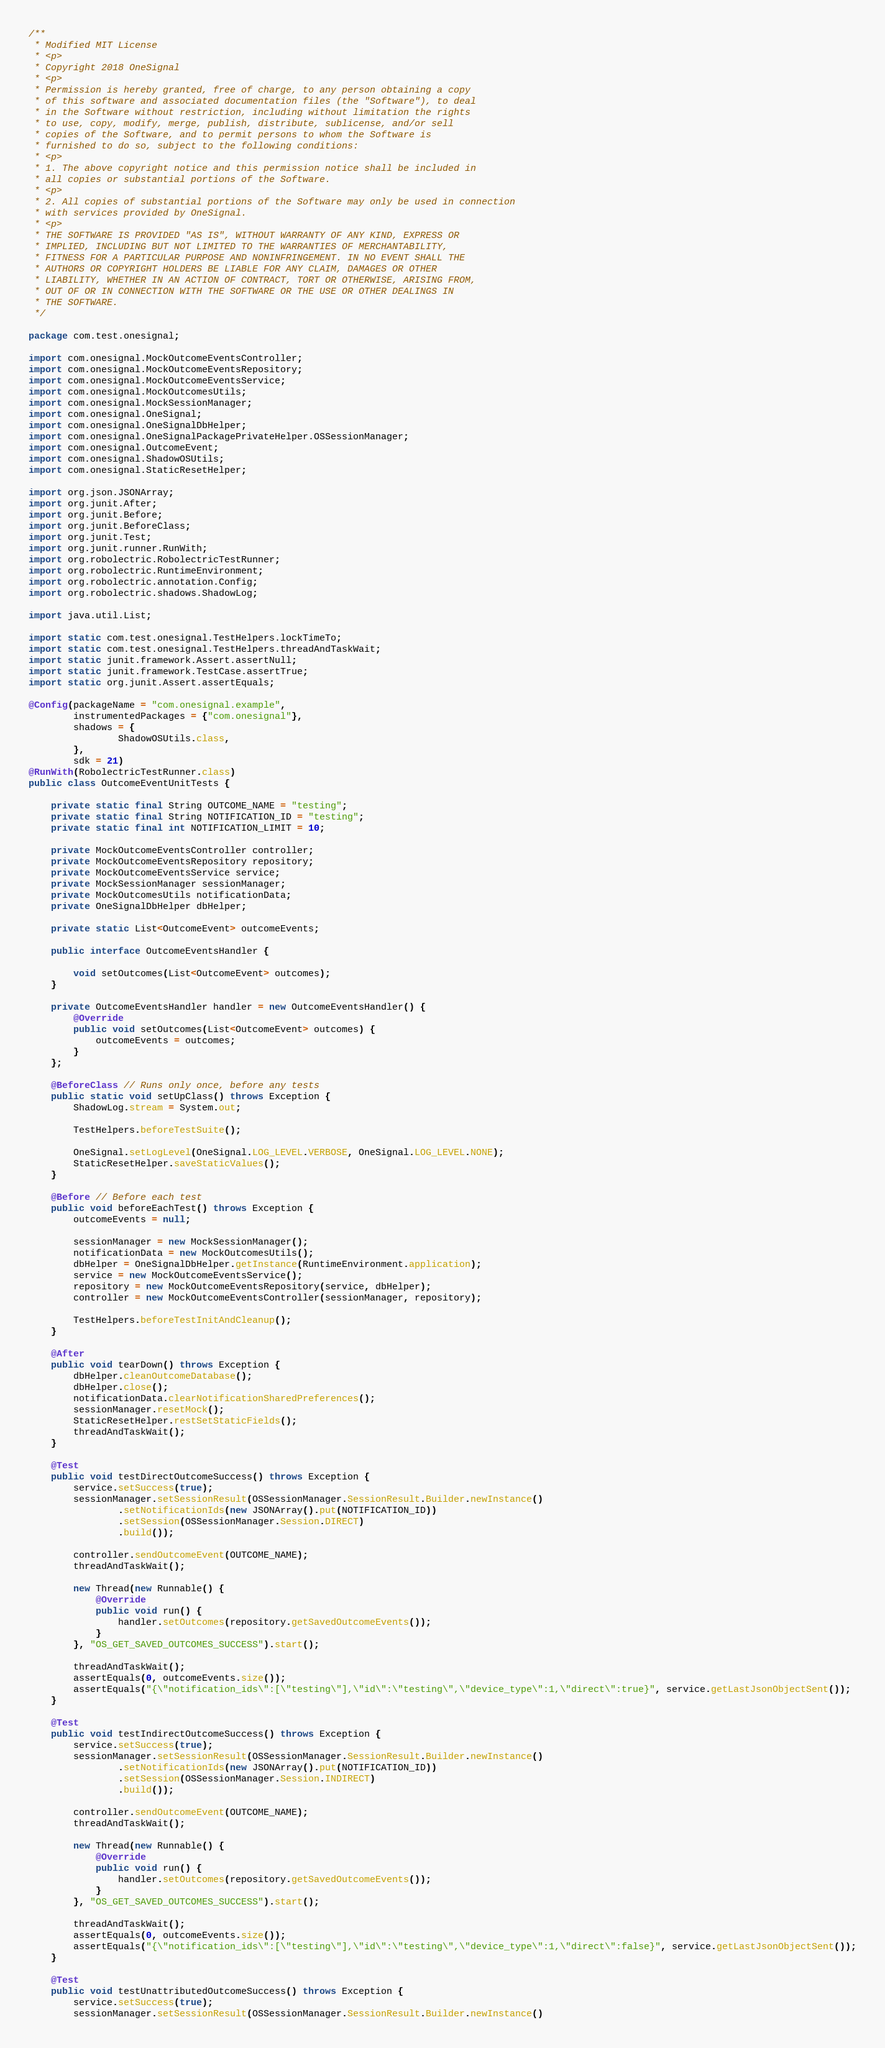Convert code to text. <code><loc_0><loc_0><loc_500><loc_500><_Java_>/**
 * Modified MIT License
 * <p>
 * Copyright 2018 OneSignal
 * <p>
 * Permission is hereby granted, free of charge, to any person obtaining a copy
 * of this software and associated documentation files (the "Software"), to deal
 * in the Software without restriction, including without limitation the rights
 * to use, copy, modify, merge, publish, distribute, sublicense, and/or sell
 * copies of the Software, and to permit persons to whom the Software is
 * furnished to do so, subject to the following conditions:
 * <p>
 * 1. The above copyright notice and this permission notice shall be included in
 * all copies or substantial portions of the Software.
 * <p>
 * 2. All copies of substantial portions of the Software may only be used in connection
 * with services provided by OneSignal.
 * <p>
 * THE SOFTWARE IS PROVIDED "AS IS", WITHOUT WARRANTY OF ANY KIND, EXPRESS OR
 * IMPLIED, INCLUDING BUT NOT LIMITED TO THE WARRANTIES OF MERCHANTABILITY,
 * FITNESS FOR A PARTICULAR PURPOSE AND NONINFRINGEMENT. IN NO EVENT SHALL THE
 * AUTHORS OR COPYRIGHT HOLDERS BE LIABLE FOR ANY CLAIM, DAMAGES OR OTHER
 * LIABILITY, WHETHER IN AN ACTION OF CONTRACT, TORT OR OTHERWISE, ARISING FROM,
 * OUT OF OR IN CONNECTION WITH THE SOFTWARE OR THE USE OR OTHER DEALINGS IN
 * THE SOFTWARE.
 */

package com.test.onesignal;

import com.onesignal.MockOutcomeEventsController;
import com.onesignal.MockOutcomeEventsRepository;
import com.onesignal.MockOutcomeEventsService;
import com.onesignal.MockOutcomesUtils;
import com.onesignal.MockSessionManager;
import com.onesignal.OneSignal;
import com.onesignal.OneSignalDbHelper;
import com.onesignal.OneSignalPackagePrivateHelper.OSSessionManager;
import com.onesignal.OutcomeEvent;
import com.onesignal.ShadowOSUtils;
import com.onesignal.StaticResetHelper;

import org.json.JSONArray;
import org.junit.After;
import org.junit.Before;
import org.junit.BeforeClass;
import org.junit.Test;
import org.junit.runner.RunWith;
import org.robolectric.RobolectricTestRunner;
import org.robolectric.RuntimeEnvironment;
import org.robolectric.annotation.Config;
import org.robolectric.shadows.ShadowLog;

import java.util.List;

import static com.test.onesignal.TestHelpers.lockTimeTo;
import static com.test.onesignal.TestHelpers.threadAndTaskWait;
import static junit.framework.Assert.assertNull;
import static junit.framework.TestCase.assertTrue;
import static org.junit.Assert.assertEquals;

@Config(packageName = "com.onesignal.example",
        instrumentedPackages = {"com.onesignal"},
        shadows = {
                ShadowOSUtils.class,
        },
        sdk = 21)
@RunWith(RobolectricTestRunner.class)
public class OutcomeEventUnitTests {

    private static final String OUTCOME_NAME = "testing";
    private static final String NOTIFICATION_ID = "testing";
    private static final int NOTIFICATION_LIMIT = 10;

    private MockOutcomeEventsController controller;
    private MockOutcomeEventsRepository repository;
    private MockOutcomeEventsService service;
    private MockSessionManager sessionManager;
    private MockOutcomesUtils notificationData;
    private OneSignalDbHelper dbHelper;

    private static List<OutcomeEvent> outcomeEvents;

    public interface OutcomeEventsHandler {

        void setOutcomes(List<OutcomeEvent> outcomes);
    }

    private OutcomeEventsHandler handler = new OutcomeEventsHandler() {
        @Override
        public void setOutcomes(List<OutcomeEvent> outcomes) {
            outcomeEvents = outcomes;
        }
    };

    @BeforeClass // Runs only once, before any tests
    public static void setUpClass() throws Exception {
        ShadowLog.stream = System.out;

        TestHelpers.beforeTestSuite();

        OneSignal.setLogLevel(OneSignal.LOG_LEVEL.VERBOSE, OneSignal.LOG_LEVEL.NONE);
        StaticResetHelper.saveStaticValues();
    }

    @Before // Before each test
    public void beforeEachTest() throws Exception {
        outcomeEvents = null;

        sessionManager = new MockSessionManager();
        notificationData = new MockOutcomesUtils();
        dbHelper = OneSignalDbHelper.getInstance(RuntimeEnvironment.application);
        service = new MockOutcomeEventsService();
        repository = new MockOutcomeEventsRepository(service, dbHelper);
        controller = new MockOutcomeEventsController(sessionManager, repository);

        TestHelpers.beforeTestInitAndCleanup();
    }

    @After
    public void tearDown() throws Exception {
        dbHelper.cleanOutcomeDatabase();
        dbHelper.close();
        notificationData.clearNotificationSharedPreferences();
        sessionManager.resetMock();
        StaticResetHelper.restSetStaticFields();
        threadAndTaskWait();
    }

    @Test
    public void testDirectOutcomeSuccess() throws Exception {
        service.setSuccess(true);
        sessionManager.setSessionResult(OSSessionManager.SessionResult.Builder.newInstance()
                .setNotificationIds(new JSONArray().put(NOTIFICATION_ID))
                .setSession(OSSessionManager.Session.DIRECT)
                .build());

        controller.sendOutcomeEvent(OUTCOME_NAME);
        threadAndTaskWait();

        new Thread(new Runnable() {
            @Override
            public void run() {
                handler.setOutcomes(repository.getSavedOutcomeEvents());
            }
        }, "OS_GET_SAVED_OUTCOMES_SUCCESS").start();

        threadAndTaskWait();
        assertEquals(0, outcomeEvents.size());
        assertEquals("{\"notification_ids\":[\"testing\"],\"id\":\"testing\",\"device_type\":1,\"direct\":true}", service.getLastJsonObjectSent());
    }

    @Test
    public void testIndirectOutcomeSuccess() throws Exception {
        service.setSuccess(true);
        sessionManager.setSessionResult(OSSessionManager.SessionResult.Builder.newInstance()
                .setNotificationIds(new JSONArray().put(NOTIFICATION_ID))
                .setSession(OSSessionManager.Session.INDIRECT)
                .build());

        controller.sendOutcomeEvent(OUTCOME_NAME);
        threadAndTaskWait();

        new Thread(new Runnable() {
            @Override
            public void run() {
                handler.setOutcomes(repository.getSavedOutcomeEvents());
            }
        }, "OS_GET_SAVED_OUTCOMES_SUCCESS").start();

        threadAndTaskWait();
        assertEquals(0, outcomeEvents.size());
        assertEquals("{\"notification_ids\":[\"testing\"],\"id\":\"testing\",\"device_type\":1,\"direct\":false}", service.getLastJsonObjectSent());
    }

    @Test
    public void testUnattributedOutcomeSuccess() throws Exception {
        service.setSuccess(true);
        sessionManager.setSessionResult(OSSessionManager.SessionResult.Builder.newInstance()</code> 